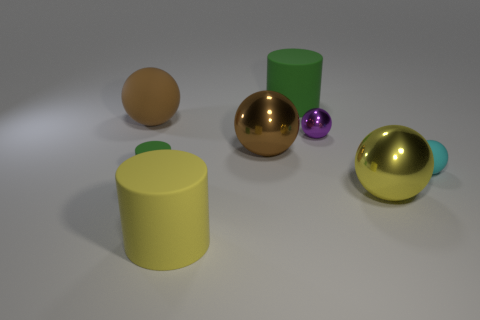What number of other things are the same size as the purple metal object?
Your answer should be compact. 2. There is a brown object behind the large brown shiny object; does it have the same shape as the tiny matte object behind the small matte cylinder?
Your response must be concise. Yes. Are there any large yellow metallic balls behind the big matte sphere?
Keep it short and to the point. No. There is another tiny thing that is the same shape as the tiny purple metal object; what color is it?
Offer a terse response. Cyan. What material is the thing that is on the left side of the tiny green cylinder?
Give a very brief answer. Rubber. There is a yellow object that is the same shape as the brown shiny thing; what is its size?
Your answer should be very brief. Large. How many brown things have the same material as the big green cylinder?
Give a very brief answer. 1. How many small shiny balls have the same color as the tiny cylinder?
Your answer should be compact. 0. How many objects are either balls right of the yellow shiny ball or large brown things that are to the left of the tiny green matte cylinder?
Provide a short and direct response. 2. Are there fewer large metal balls that are on the right side of the tiny purple ball than yellow rubber cylinders?
Your answer should be compact. No. 